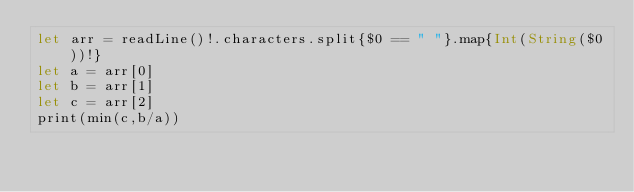Convert code to text. <code><loc_0><loc_0><loc_500><loc_500><_Swift_>let arr = readLine()!.characters.split{$0 == " "}.map{Int(String($0))!}
let a = arr[0]
let b = arr[1]
let c = arr[2]
print(min(c,b/a))</code> 